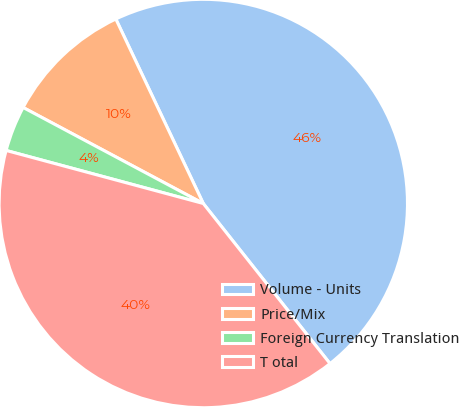<chart> <loc_0><loc_0><loc_500><loc_500><pie_chart><fcel>Volume - Units<fcel>Price/Mix<fcel>Foreign Currency Translation<fcel>T otal<nl><fcel>46.39%<fcel>10.16%<fcel>3.61%<fcel>39.84%<nl></chart> 